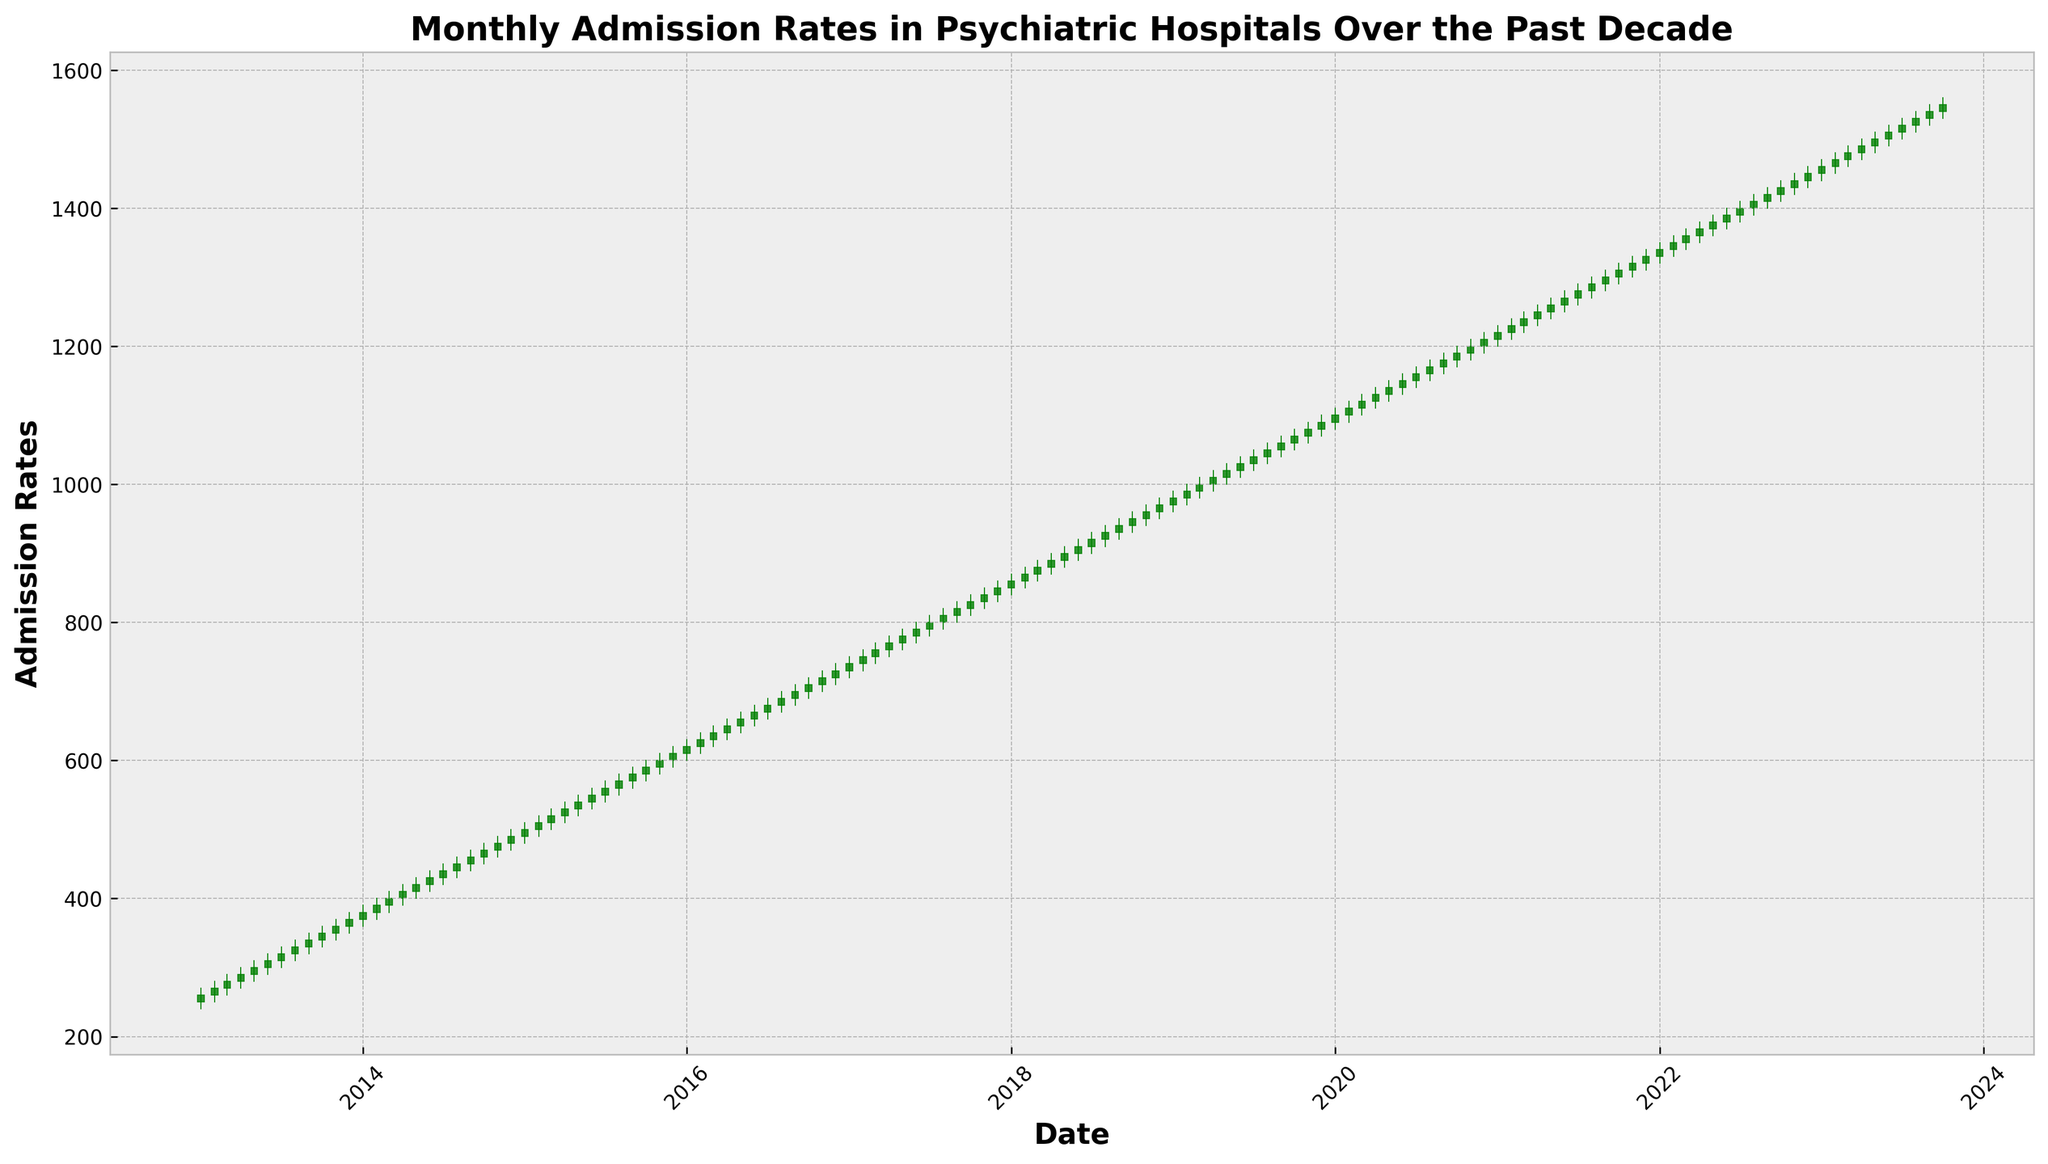Which year had the highest admission rate at the end of the year? Look at the last candlestick for each year and compare the 'Close' prices. Identify the highest 'Close' among all end-of-year data points.
Answer: 2023 When did the largest month-over-month increase in admission rates occur? Compare the 'Close' price of each month with the 'Close' price of the previous month. Identify the month with the largest difference.
Answer: April 2020 How many times did the admission rates close higher than they opened in the entire decade? Count the number of candlesticks where the 'Close' price is higher than the 'Open' price. These will be the green candlesticks in the figure.
Answer: 90 times Between which consecutive years did the admission rates rise the most from start to finish? Calculate the difference between the 'Close' price of December of the previous year and the 'Close' price of December of the current year for each year-pair and identify the highest difference.
Answer: 2019-2020 What was the general trend of admission rates from 2013 to 2023? Observe the overall direction of the candlestick markers from the beginning to the end of the chart. Note the pattern of increasing or decreasing series over the years.
Answer: Upward trend Identify a period with the smallest fluctuations in admission rates. Look at the length of the candlesticks for various periods. Determine the period where the difference between 'High' and 'Low' prices is minimal.
Answer: 2016 Which month had the lowest admission rate in the entire data set? Find the candlestick with the lowest 'Low' price throughout the entire chart.
Answer: January 2013 How much did the admission rates increase from the beginning to the end of 2017? Find the 'Open' price of January 2017 and the 'Close' price of December 2017, then calculate the difference between these values.
Answer: 100 points Did any year see admission rates decreasing overall? Check the 'Close' price of December compared to the 'Close' price of January for each year. Identify if there's any year where the December 'Close' is lower than January's.
Answer: No 